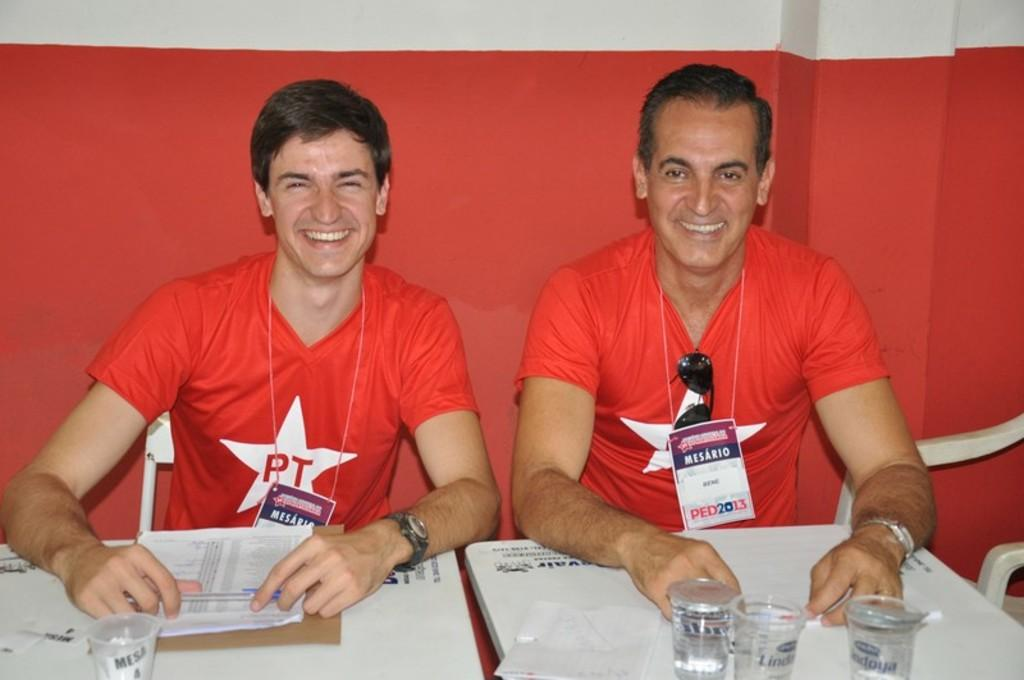<image>
Offer a succinct explanation of the picture presented. Two men wearing red shirts with a star on the front containing the letters PT sit at a table. 